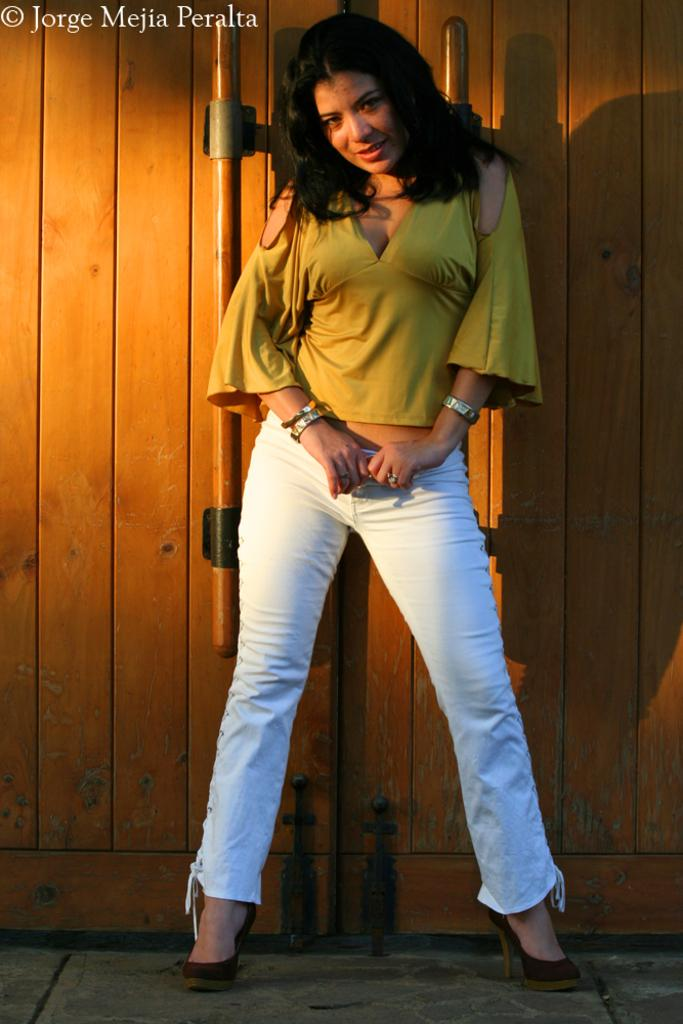Who is present in the image? There is a woman in the image. What type of footwear is the woman wearing? The woman is wearing heels. What is the woman's position in the image? The woman is standing on a surface. What can be seen in the background of the image? There is a wooden door in the background of the image. What is present in the top left corner of the image? There is text in the top left corner of the image. Is there a guitar being played in the image? There is no guitar present in the image. Is the woman attending a meeting in the image? The image does not provide any information about a meeting or the woman's purpose in the image. 